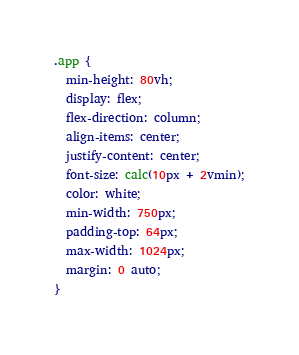Convert code to text. <code><loc_0><loc_0><loc_500><loc_500><_CSS_>.app {
  min-height: 80vh;
  display: flex;
  flex-direction: column;
  align-items: center;
  justify-content: center;
  font-size: calc(10px + 2vmin);
  color: white;
  min-width: 750px;
  padding-top: 64px;
  max-width: 1024px;
  margin: 0 auto;
}
</code> 